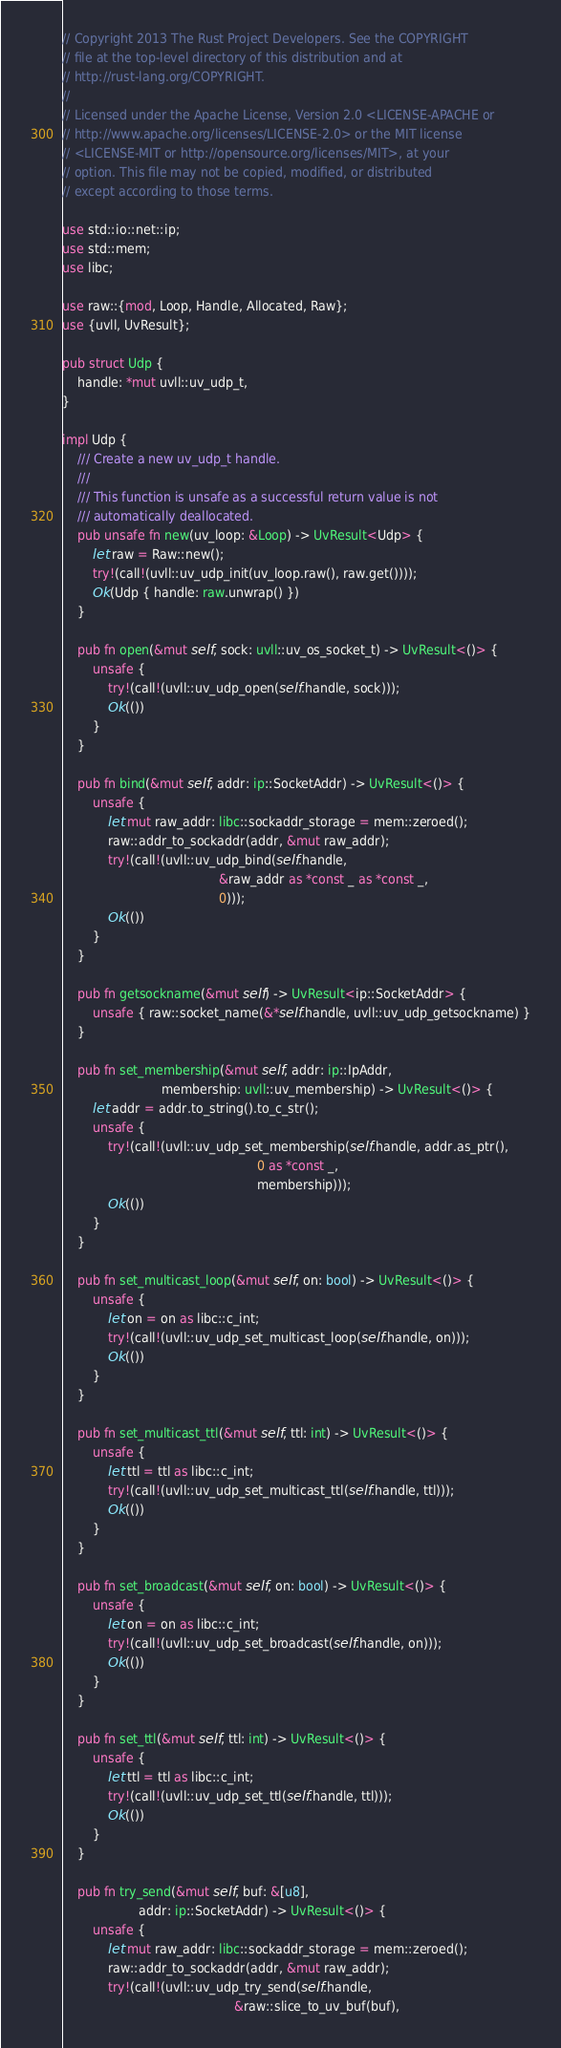<code> <loc_0><loc_0><loc_500><loc_500><_Rust_>// Copyright 2013 The Rust Project Developers. See the COPYRIGHT
// file at the top-level directory of this distribution and at
// http://rust-lang.org/COPYRIGHT.
//
// Licensed under the Apache License, Version 2.0 <LICENSE-APACHE or
// http://www.apache.org/licenses/LICENSE-2.0> or the MIT license
// <LICENSE-MIT or http://opensource.org/licenses/MIT>, at your
// option. This file may not be copied, modified, or distributed
// except according to those terms.

use std::io::net::ip;
use std::mem;
use libc;

use raw::{mod, Loop, Handle, Allocated, Raw};
use {uvll, UvResult};

pub struct Udp {
    handle: *mut uvll::uv_udp_t,
}

impl Udp {
    /// Create a new uv_udp_t handle.
    ///
    /// This function is unsafe as a successful return value is not
    /// automatically deallocated.
    pub unsafe fn new(uv_loop: &Loop) -> UvResult<Udp> {
        let raw = Raw::new();
        try!(call!(uvll::uv_udp_init(uv_loop.raw(), raw.get())));
        Ok(Udp { handle: raw.unwrap() })
    }

    pub fn open(&mut self, sock: uvll::uv_os_socket_t) -> UvResult<()> {
        unsafe {
            try!(call!(uvll::uv_udp_open(self.handle, sock)));
            Ok(())
        }
    }

    pub fn bind(&mut self, addr: ip::SocketAddr) -> UvResult<()> {
        unsafe {
            let mut raw_addr: libc::sockaddr_storage = mem::zeroed();
            raw::addr_to_sockaddr(addr, &mut raw_addr);
            try!(call!(uvll::uv_udp_bind(self.handle,
                                         &raw_addr as *const _ as *const _,
                                         0)));
            Ok(())
        }
    }

    pub fn getsockname(&mut self) -> UvResult<ip::SocketAddr> {
        unsafe { raw::socket_name(&*self.handle, uvll::uv_udp_getsockname) }
    }

    pub fn set_membership(&mut self, addr: ip::IpAddr,
                          membership: uvll::uv_membership) -> UvResult<()> {
        let addr = addr.to_string().to_c_str();
        unsafe {
            try!(call!(uvll::uv_udp_set_membership(self.handle, addr.as_ptr(),
                                                   0 as *const _,
                                                   membership)));
            Ok(())
        }
    }

    pub fn set_multicast_loop(&mut self, on: bool) -> UvResult<()> {
        unsafe {
            let on = on as libc::c_int;
            try!(call!(uvll::uv_udp_set_multicast_loop(self.handle, on)));
            Ok(())
        }
    }

    pub fn set_multicast_ttl(&mut self, ttl: int) -> UvResult<()> {
        unsafe {
            let ttl = ttl as libc::c_int;
            try!(call!(uvll::uv_udp_set_multicast_ttl(self.handle, ttl)));
            Ok(())
        }
    }

    pub fn set_broadcast(&mut self, on: bool) -> UvResult<()> {
        unsafe {
            let on = on as libc::c_int;
            try!(call!(uvll::uv_udp_set_broadcast(self.handle, on)));
            Ok(())
        }
    }

    pub fn set_ttl(&mut self, ttl: int) -> UvResult<()> {
        unsafe {
            let ttl = ttl as libc::c_int;
            try!(call!(uvll::uv_udp_set_ttl(self.handle, ttl)));
            Ok(())
        }
    }

    pub fn try_send(&mut self, buf: &[u8],
                    addr: ip::SocketAddr) -> UvResult<()> {
        unsafe {
            let mut raw_addr: libc::sockaddr_storage = mem::zeroed();
            raw::addr_to_sockaddr(addr, &mut raw_addr);
            try!(call!(uvll::uv_udp_try_send(self.handle,
                                             &raw::slice_to_uv_buf(buf),</code> 